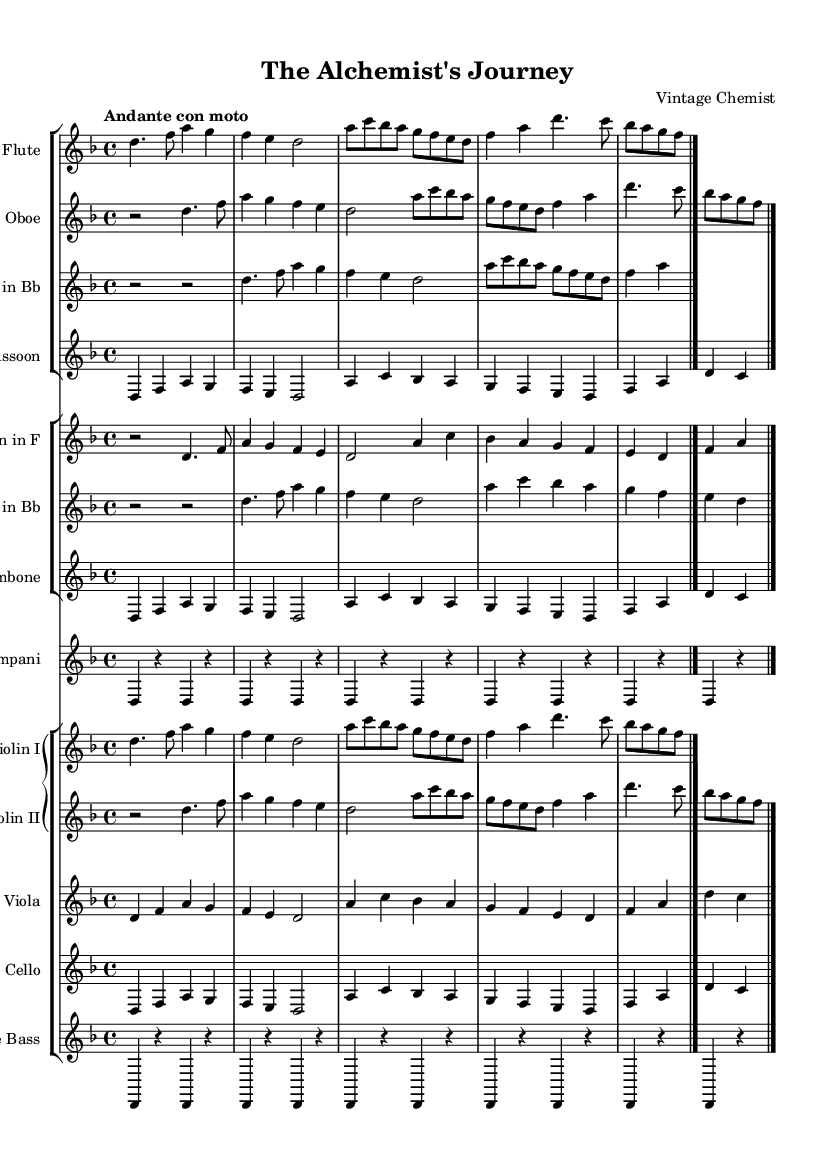What is the key signature of this music? The key signature is indicated at the beginning of the score, which shows two flat symbols (B♭ and E♭). This means the piece is in D minor, as D minor has one flat in its key signature.
Answer: D minor What is the time signature of this piece? The time signature is shown near the beginning of the score, which displays "4/4." This indicates that there are four beats per measure and the quarter note receives one beat.
Answer: 4/4 What is the tempo marking for this composition? The tempo marking is indicated early in the score as "Andante con moto." This suggests a moderately slow tempo that moves with a bit of motion.
Answer: Andante con moto Which instrument has the highest range in this score? By analyzing the musical lines, the flute typically plays notes in a higher register compared to the other instruments. The flute's entrance is prominent and features the highest pitches.
Answer: Flute How many instruments are used in this symphonic poem? In the score, there is a total of 12 individual staves displayed, representing different instruments such as woodwinds, brass, and strings. Counting all the grouped and individual staves, the total number of unique instruments is 10.
Answer: 10 What is the primary thematic material based on the title of this piece? The title "The Alchemist's Journey" suggests that the thematic material likely explores the evolution of chemistry. Therefore, one can deduce the main ideas are based on historical elements corresponding to alchemy and chemistry transformation, reflected in the motifs and melodies found throughout the score.
Answer: Chemistry How many beats does a measure typically contain in this composition? Since the time signature is presented as 4/4, it means each measure contains four beats. Hence, each measure can be counted to verify this consistent structure throughout the piece, adhering to the common time signature.
Answer: 4 